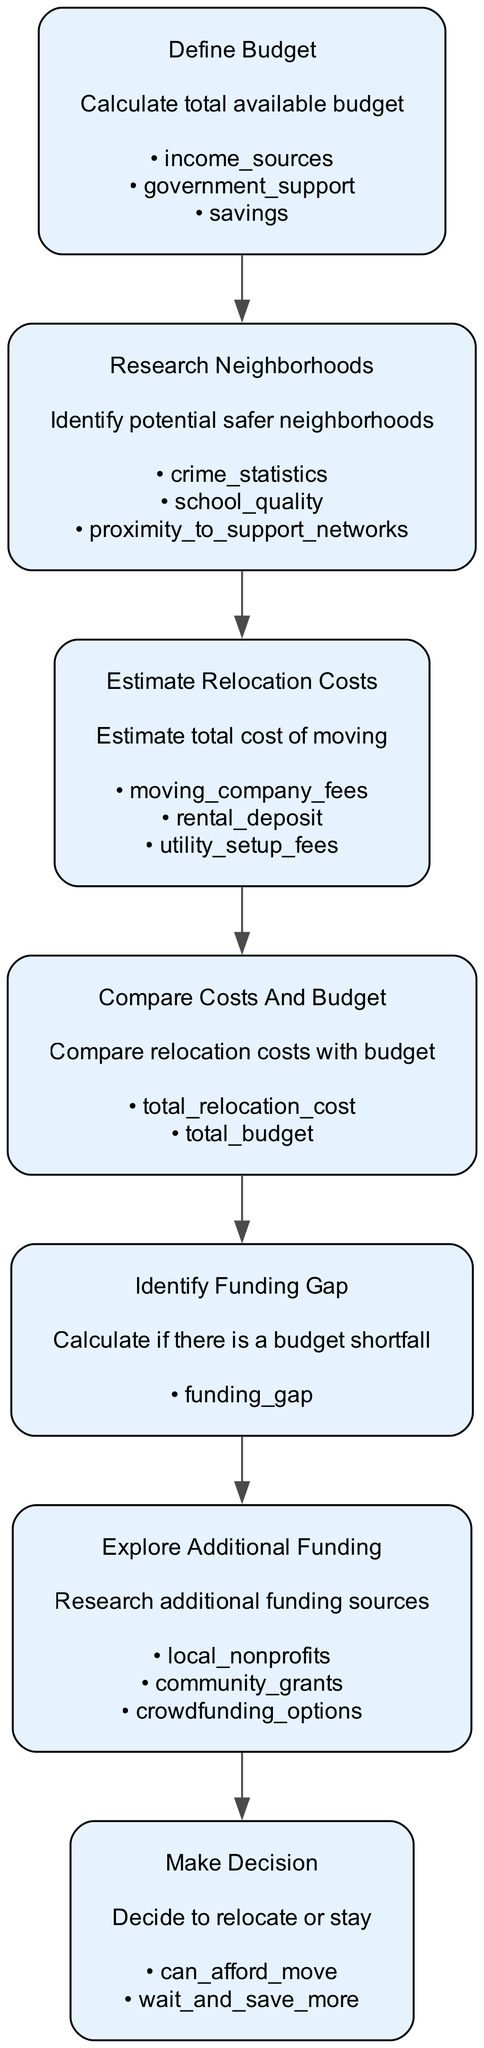What's the first step in the diagram? The diagram begins with the "Define Budget" step. This is the initial action that sets the financial context for all subsequent steps in the flowchart.
Answer: Define Budget How many total steps are in the flowchart? The flowchart comprises a total of 7 steps. This includes all actions taken from budget definition to decision-making.
Answer: 7 What is the final step in the flowchart? The last step indicated in the flowchart is "Make Decision," which assesses whether to relocate or stay based on the budget analysis.
Answer: Make Decision What does the "Explore Additional Funding" step involve? This step includes researching potential financial sources to bridge a budget shortfall, such as local nonprofits, community grants, and crowdfunding options.
Answer: local nonprofits, community grants, crowdfunding options What comes after "Estimate Relocation Costs"? Following "Estimate Relocation Costs," the next step is "Compare Costs and Budget," where the estimated costs are evaluated against the available budget.
Answer: Compare Costs and Budget If there is a funding gap, what is the next action to take? If a funding gap exists, the next step is to "Explore Additional Funding" to identify possible sources to cover the shortfall.
Answer: Explore Additional Funding What are the details listed under the "Research Neighborhoods" step? The details for "Research Neighborhoods" include crime statistics, school quality, and proximity to support networks, which are crucial for assessing the safety of potential new neighborhoods.
Answer: crime statistics, school quality, proximity to support networks 